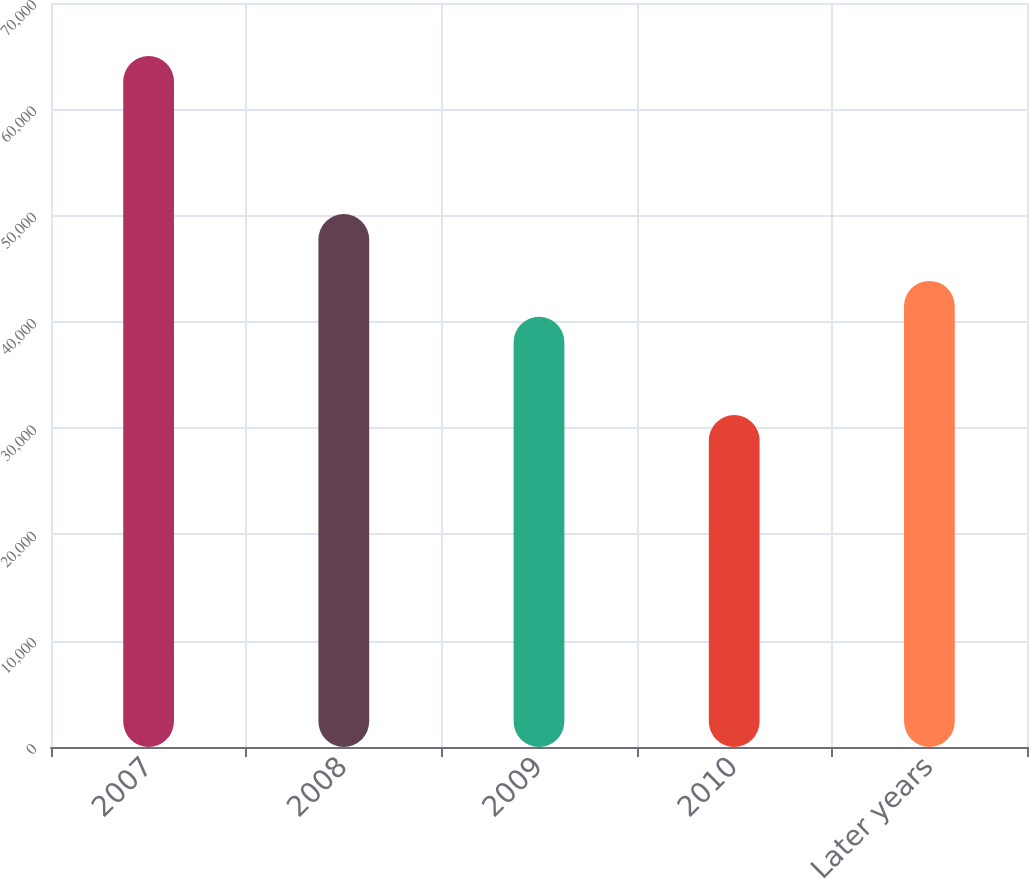Convert chart to OTSL. <chart><loc_0><loc_0><loc_500><loc_500><bar_chart><fcel>2007<fcel>2008<fcel>2009<fcel>2010<fcel>Later years<nl><fcel>65002<fcel>50145<fcel>40477<fcel>31225<fcel>43854.7<nl></chart> 